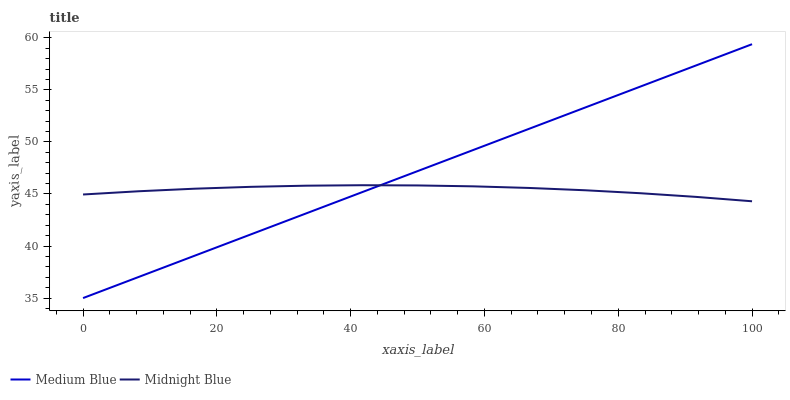Does Midnight Blue have the minimum area under the curve?
Answer yes or no. Yes. Does Medium Blue have the maximum area under the curve?
Answer yes or no. Yes. Does Midnight Blue have the maximum area under the curve?
Answer yes or no. No. Is Medium Blue the smoothest?
Answer yes or no. Yes. Is Midnight Blue the roughest?
Answer yes or no. Yes. Is Midnight Blue the smoothest?
Answer yes or no. No. Does Medium Blue have the lowest value?
Answer yes or no. Yes. Does Midnight Blue have the lowest value?
Answer yes or no. No. Does Medium Blue have the highest value?
Answer yes or no. Yes. Does Midnight Blue have the highest value?
Answer yes or no. No. Does Midnight Blue intersect Medium Blue?
Answer yes or no. Yes. Is Midnight Blue less than Medium Blue?
Answer yes or no. No. Is Midnight Blue greater than Medium Blue?
Answer yes or no. No. 